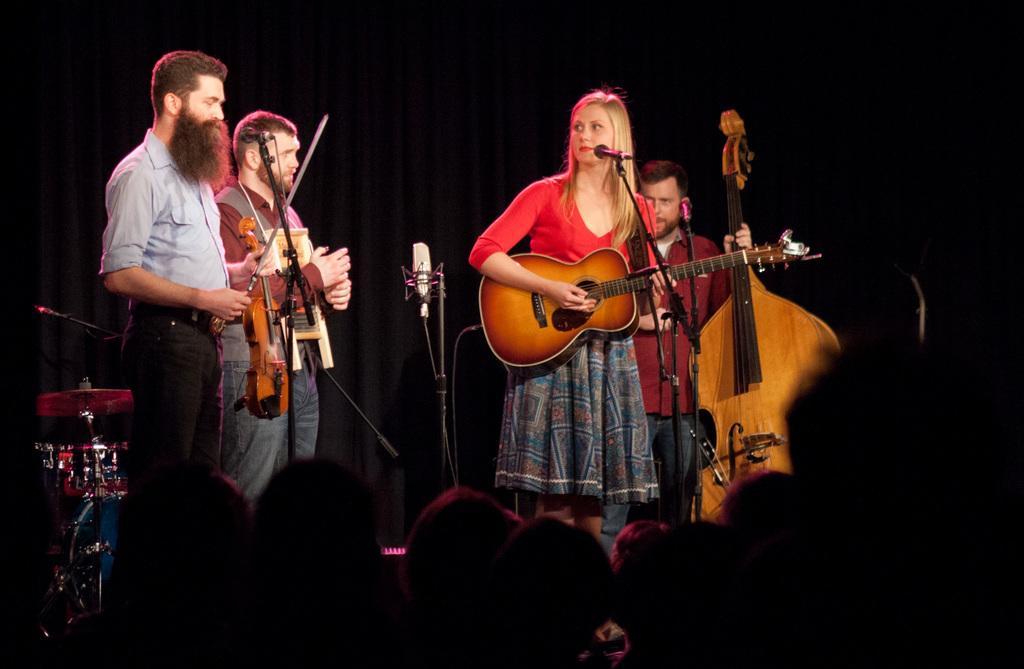How would you summarize this image in a sentence or two? In the picture we can see four people standing, three are men and one is woman, three people are holding a guitars and one woman is also holding a guitar near the micro phone, she is wearing the red top and skirt. In the background we can see some musical instruments. 